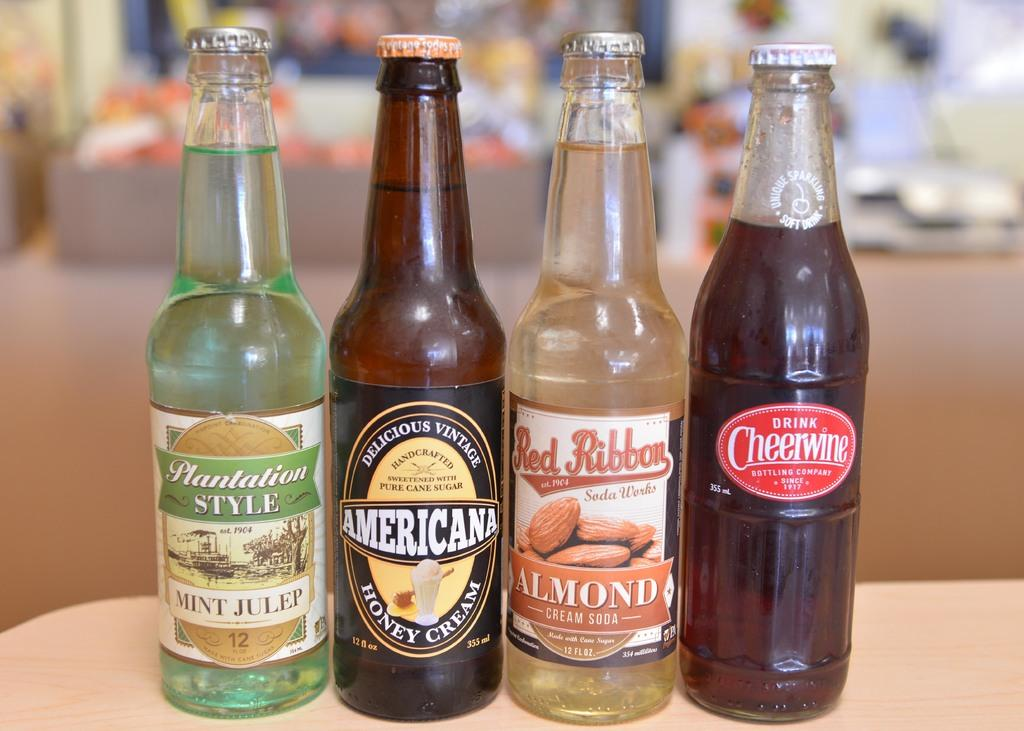Provide a one-sentence caption for the provided image. A line of drink bottles one of which is by the brand American. 